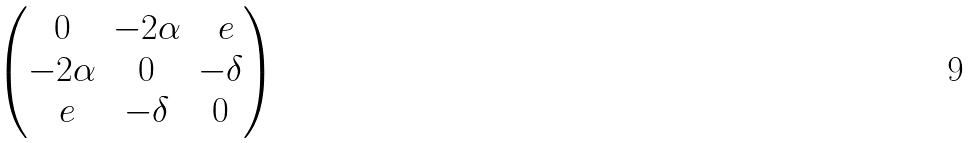<formula> <loc_0><loc_0><loc_500><loc_500>\begin{pmatrix} 0 & - 2 \alpha & \ e \\ - 2 \alpha & 0 & - \delta \\ \ e & - \delta & 0 \end{pmatrix}</formula> 